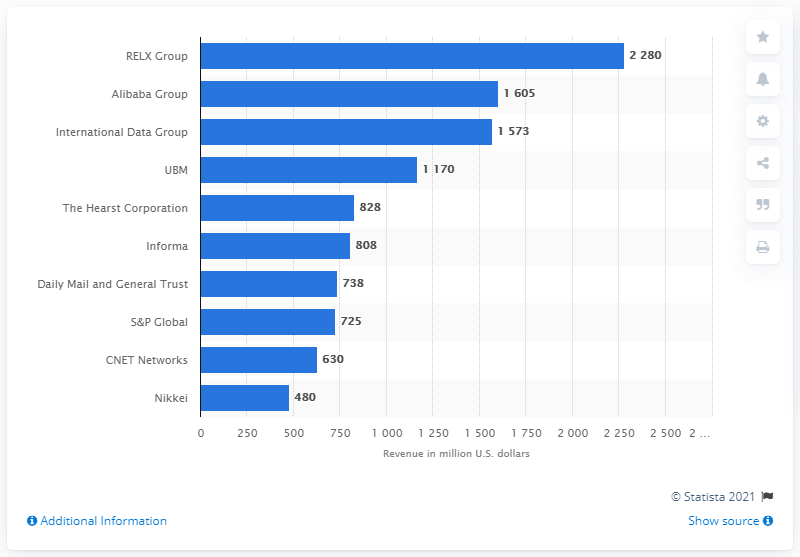Specify some key components in this picture. RELX's revenue in the measured period was 2280. 